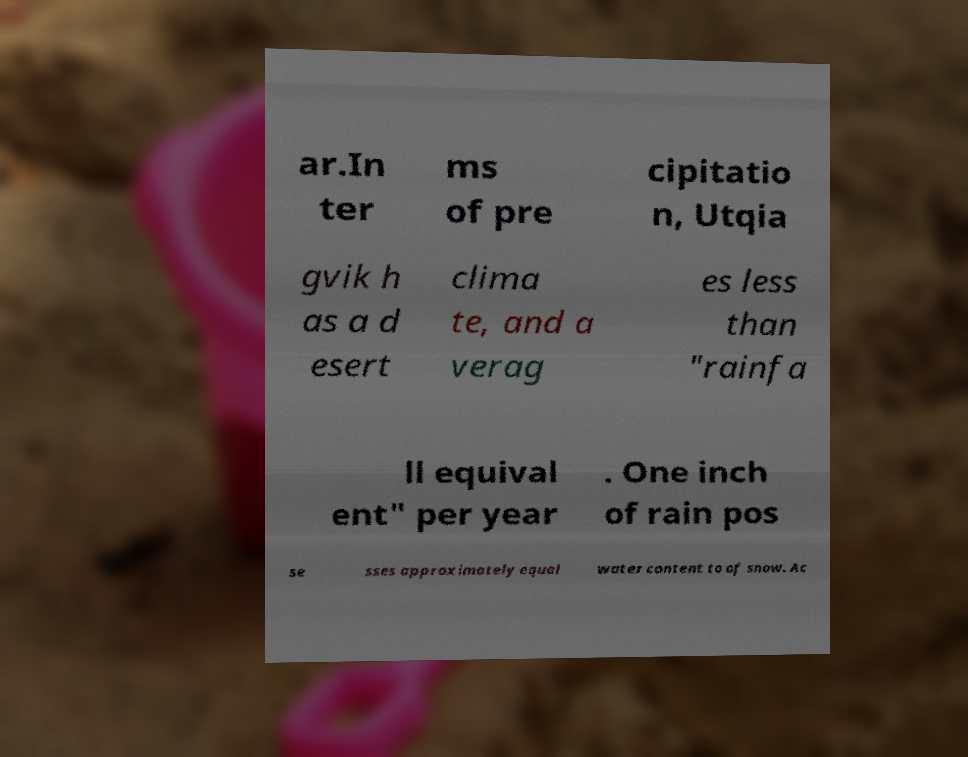Can you accurately transcribe the text from the provided image for me? ar.In ter ms of pre cipitatio n, Utqia gvik h as a d esert clima te, and a verag es less than "rainfa ll equival ent" per year . One inch of rain pos se sses approximately equal water content to of snow. Ac 